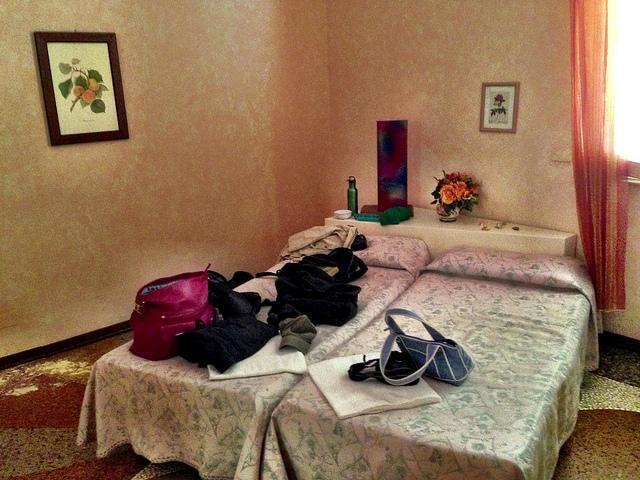How many handbags are in the picture?
Give a very brief answer. 2. How many beds are there?
Give a very brief answer. 2. 